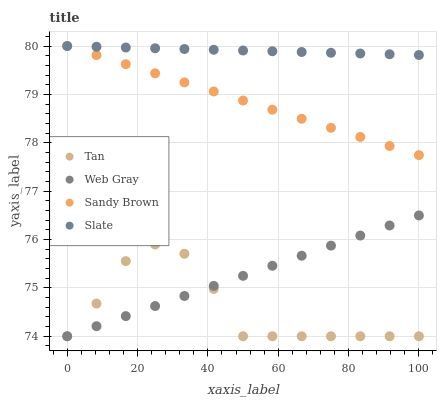Does Tan have the minimum area under the curve?
Answer yes or no. Yes. Does Slate have the maximum area under the curve?
Answer yes or no. Yes. Does Web Gray have the minimum area under the curve?
Answer yes or no. No. Does Web Gray have the maximum area under the curve?
Answer yes or no. No. Is Web Gray the smoothest?
Answer yes or no. Yes. Is Tan the roughest?
Answer yes or no. Yes. Is Sandy Brown the smoothest?
Answer yes or no. No. Is Sandy Brown the roughest?
Answer yes or no. No. Does Tan have the lowest value?
Answer yes or no. Yes. Does Sandy Brown have the lowest value?
Answer yes or no. No. Does Slate have the highest value?
Answer yes or no. Yes. Does Web Gray have the highest value?
Answer yes or no. No. Is Web Gray less than Slate?
Answer yes or no. Yes. Is Slate greater than Tan?
Answer yes or no. Yes. Does Slate intersect Sandy Brown?
Answer yes or no. Yes. Is Slate less than Sandy Brown?
Answer yes or no. No. Is Slate greater than Sandy Brown?
Answer yes or no. No. Does Web Gray intersect Slate?
Answer yes or no. No. 